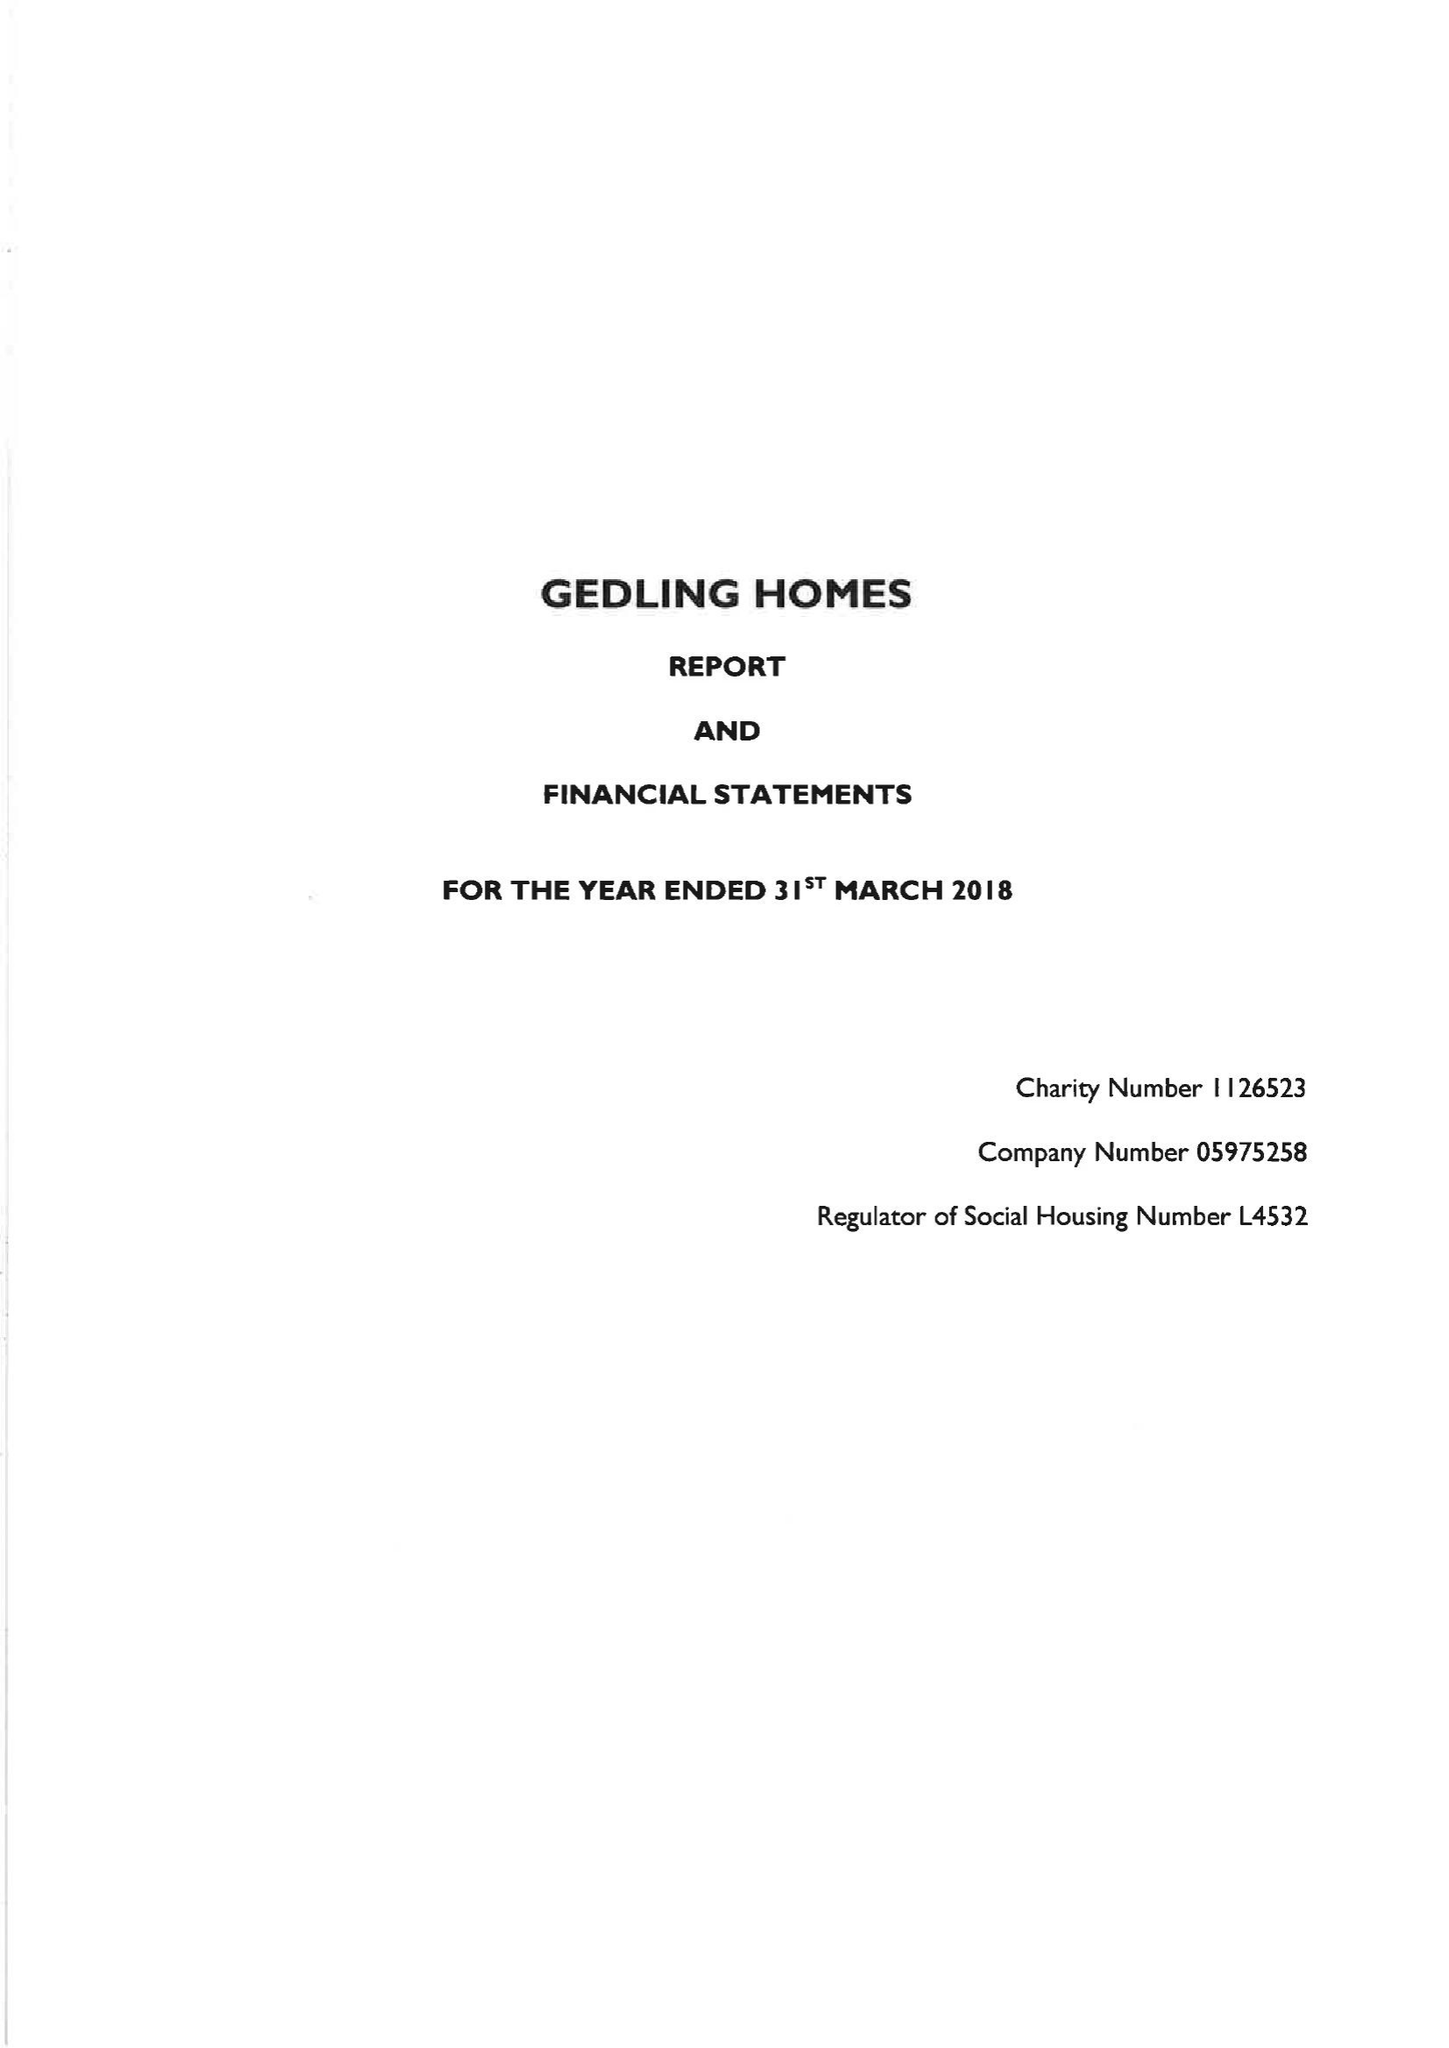What is the value for the report_date?
Answer the question using a single word or phrase. 2018-03-31 